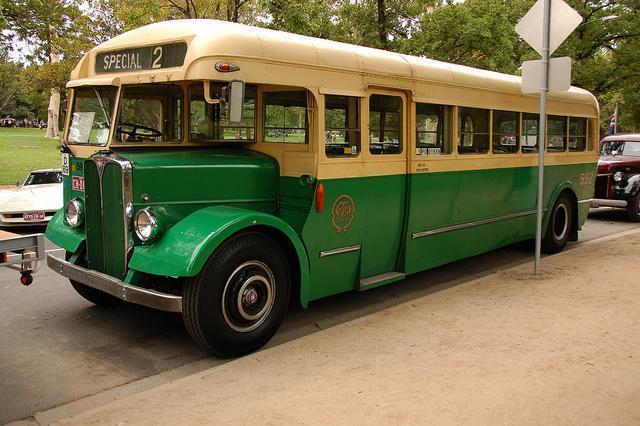How many windows on the right side of the bus?
Give a very brief answer. 8. How many cars can you see?
Give a very brief answer. 2. 